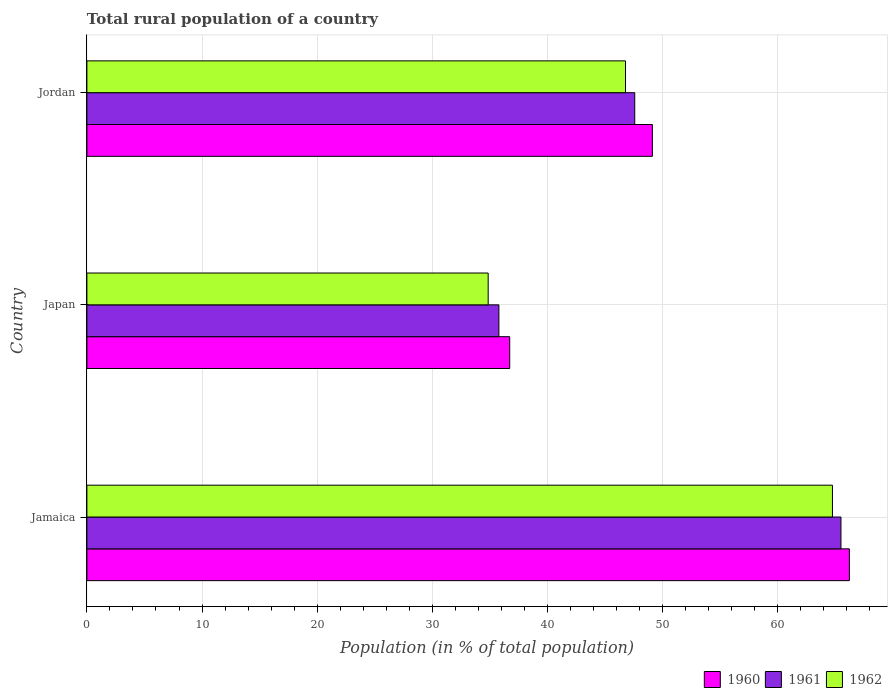Are the number of bars per tick equal to the number of legend labels?
Provide a succinct answer. Yes. What is the label of the 3rd group of bars from the top?
Offer a very short reply. Jamaica. In how many cases, is the number of bars for a given country not equal to the number of legend labels?
Ensure brevity in your answer.  0. What is the rural population in 1962 in Jordan?
Provide a short and direct response. 46.78. Across all countries, what is the maximum rural population in 1961?
Make the answer very short. 65.5. Across all countries, what is the minimum rural population in 1961?
Give a very brief answer. 35.79. In which country was the rural population in 1960 maximum?
Your response must be concise. Jamaica. What is the total rural population in 1960 in the graph?
Your answer should be compact. 152.08. What is the difference between the rural population in 1961 in Japan and that in Jordan?
Make the answer very short. -11.8. What is the difference between the rural population in 1960 in Jordan and the rural population in 1962 in Jamaica?
Offer a terse response. -15.64. What is the average rural population in 1962 per country?
Provide a short and direct response. 48.8. What is the difference between the rural population in 1962 and rural population in 1960 in Japan?
Offer a very short reply. -1.87. What is the ratio of the rural population in 1960 in Jamaica to that in Jordan?
Your answer should be very brief. 1.35. What is the difference between the highest and the second highest rural population in 1961?
Your answer should be very brief. 17.91. What is the difference between the highest and the lowest rural population in 1961?
Make the answer very short. 29.71. In how many countries, is the rural population in 1961 greater than the average rural population in 1961 taken over all countries?
Offer a terse response. 1. Is the sum of the rural population in 1961 in Japan and Jordan greater than the maximum rural population in 1960 across all countries?
Provide a short and direct response. Yes. What does the 3rd bar from the top in Jamaica represents?
Ensure brevity in your answer.  1960. What does the 3rd bar from the bottom in Japan represents?
Your answer should be compact. 1962. Are all the bars in the graph horizontal?
Make the answer very short. Yes. How many countries are there in the graph?
Offer a terse response. 3. What is the difference between two consecutive major ticks on the X-axis?
Make the answer very short. 10. Are the values on the major ticks of X-axis written in scientific E-notation?
Make the answer very short. No. Does the graph contain grids?
Make the answer very short. Yes. How many legend labels are there?
Keep it short and to the point. 3. What is the title of the graph?
Your response must be concise. Total rural population of a country. Does "1970" appear as one of the legend labels in the graph?
Give a very brief answer. No. What is the label or title of the X-axis?
Offer a terse response. Population (in % of total population). What is the label or title of the Y-axis?
Provide a short and direct response. Country. What is the Population (in % of total population) in 1960 in Jamaica?
Offer a terse response. 66.23. What is the Population (in % of total population) in 1961 in Jamaica?
Keep it short and to the point. 65.5. What is the Population (in % of total population) in 1962 in Jamaica?
Your answer should be very brief. 64.76. What is the Population (in % of total population) in 1960 in Japan?
Offer a very short reply. 36.73. What is the Population (in % of total population) in 1961 in Japan?
Your response must be concise. 35.79. What is the Population (in % of total population) of 1962 in Japan?
Ensure brevity in your answer.  34.86. What is the Population (in % of total population) of 1960 in Jordan?
Give a very brief answer. 49.12. What is the Population (in % of total population) in 1961 in Jordan?
Give a very brief answer. 47.59. What is the Population (in % of total population) of 1962 in Jordan?
Give a very brief answer. 46.78. Across all countries, what is the maximum Population (in % of total population) of 1960?
Give a very brief answer. 66.23. Across all countries, what is the maximum Population (in % of total population) in 1961?
Offer a terse response. 65.5. Across all countries, what is the maximum Population (in % of total population) in 1962?
Give a very brief answer. 64.76. Across all countries, what is the minimum Population (in % of total population) in 1960?
Provide a succinct answer. 36.73. Across all countries, what is the minimum Population (in % of total population) in 1961?
Keep it short and to the point. 35.79. Across all countries, what is the minimum Population (in % of total population) in 1962?
Ensure brevity in your answer.  34.86. What is the total Population (in % of total population) in 1960 in the graph?
Give a very brief answer. 152.08. What is the total Population (in % of total population) of 1961 in the graph?
Provide a succinct answer. 148.88. What is the total Population (in % of total population) in 1962 in the graph?
Offer a very short reply. 146.4. What is the difference between the Population (in % of total population) of 1960 in Jamaica and that in Japan?
Provide a succinct answer. 29.5. What is the difference between the Population (in % of total population) in 1961 in Jamaica and that in Japan?
Make the answer very short. 29.71. What is the difference between the Population (in % of total population) in 1962 in Jamaica and that in Japan?
Keep it short and to the point. 29.91. What is the difference between the Population (in % of total population) of 1960 in Jamaica and that in Jordan?
Ensure brevity in your answer.  17.11. What is the difference between the Population (in % of total population) of 1961 in Jamaica and that in Jordan?
Your answer should be very brief. 17.91. What is the difference between the Population (in % of total population) of 1962 in Jamaica and that in Jordan?
Provide a succinct answer. 17.98. What is the difference between the Population (in % of total population) of 1960 in Japan and that in Jordan?
Your answer should be very brief. -12.39. What is the difference between the Population (in % of total population) in 1961 in Japan and that in Jordan?
Provide a succinct answer. -11.8. What is the difference between the Population (in % of total population) in 1962 in Japan and that in Jordan?
Give a very brief answer. -11.93. What is the difference between the Population (in % of total population) of 1960 in Jamaica and the Population (in % of total population) of 1961 in Japan?
Provide a short and direct response. 30.44. What is the difference between the Population (in % of total population) in 1960 in Jamaica and the Population (in % of total population) in 1962 in Japan?
Offer a terse response. 31.38. What is the difference between the Population (in % of total population) in 1961 in Jamaica and the Population (in % of total population) in 1962 in Japan?
Ensure brevity in your answer.  30.64. What is the difference between the Population (in % of total population) in 1960 in Jamaica and the Population (in % of total population) in 1961 in Jordan?
Your answer should be compact. 18.64. What is the difference between the Population (in % of total population) in 1960 in Jamaica and the Population (in % of total population) in 1962 in Jordan?
Provide a succinct answer. 19.45. What is the difference between the Population (in % of total population) in 1961 in Jamaica and the Population (in % of total population) in 1962 in Jordan?
Your answer should be very brief. 18.71. What is the difference between the Population (in % of total population) in 1960 in Japan and the Population (in % of total population) in 1961 in Jordan?
Provide a succinct answer. -10.86. What is the difference between the Population (in % of total population) in 1960 in Japan and the Population (in % of total population) in 1962 in Jordan?
Offer a terse response. -10.06. What is the difference between the Population (in % of total population) in 1961 in Japan and the Population (in % of total population) in 1962 in Jordan?
Offer a terse response. -11. What is the average Population (in % of total population) of 1960 per country?
Keep it short and to the point. 50.69. What is the average Population (in % of total population) in 1961 per country?
Offer a terse response. 49.62. What is the average Population (in % of total population) in 1962 per country?
Offer a terse response. 48.8. What is the difference between the Population (in % of total population) in 1960 and Population (in % of total population) in 1961 in Jamaica?
Provide a short and direct response. 0.73. What is the difference between the Population (in % of total population) in 1960 and Population (in % of total population) in 1962 in Jamaica?
Provide a short and direct response. 1.47. What is the difference between the Population (in % of total population) in 1961 and Population (in % of total population) in 1962 in Jamaica?
Provide a short and direct response. 0.74. What is the difference between the Population (in % of total population) of 1960 and Population (in % of total population) of 1961 in Japan?
Give a very brief answer. 0.94. What is the difference between the Population (in % of total population) of 1960 and Population (in % of total population) of 1962 in Japan?
Your response must be concise. 1.87. What is the difference between the Population (in % of total population) in 1961 and Population (in % of total population) in 1962 in Japan?
Make the answer very short. 0.93. What is the difference between the Population (in % of total population) in 1960 and Population (in % of total population) in 1961 in Jordan?
Provide a succinct answer. 1.53. What is the difference between the Population (in % of total population) of 1960 and Population (in % of total population) of 1962 in Jordan?
Ensure brevity in your answer.  2.34. What is the difference between the Population (in % of total population) of 1961 and Population (in % of total population) of 1962 in Jordan?
Ensure brevity in your answer.  0.8. What is the ratio of the Population (in % of total population) of 1960 in Jamaica to that in Japan?
Provide a succinct answer. 1.8. What is the ratio of the Population (in % of total population) in 1961 in Jamaica to that in Japan?
Provide a succinct answer. 1.83. What is the ratio of the Population (in % of total population) of 1962 in Jamaica to that in Japan?
Provide a succinct answer. 1.86. What is the ratio of the Population (in % of total population) of 1960 in Jamaica to that in Jordan?
Your answer should be very brief. 1.35. What is the ratio of the Population (in % of total population) of 1961 in Jamaica to that in Jordan?
Keep it short and to the point. 1.38. What is the ratio of the Population (in % of total population) of 1962 in Jamaica to that in Jordan?
Provide a short and direct response. 1.38. What is the ratio of the Population (in % of total population) in 1960 in Japan to that in Jordan?
Your answer should be compact. 0.75. What is the ratio of the Population (in % of total population) in 1961 in Japan to that in Jordan?
Offer a terse response. 0.75. What is the ratio of the Population (in % of total population) of 1962 in Japan to that in Jordan?
Give a very brief answer. 0.74. What is the difference between the highest and the second highest Population (in % of total population) in 1960?
Provide a short and direct response. 17.11. What is the difference between the highest and the second highest Population (in % of total population) of 1961?
Give a very brief answer. 17.91. What is the difference between the highest and the second highest Population (in % of total population) in 1962?
Offer a very short reply. 17.98. What is the difference between the highest and the lowest Population (in % of total population) of 1960?
Your answer should be very brief. 29.5. What is the difference between the highest and the lowest Population (in % of total population) of 1961?
Offer a very short reply. 29.71. What is the difference between the highest and the lowest Population (in % of total population) in 1962?
Offer a terse response. 29.91. 